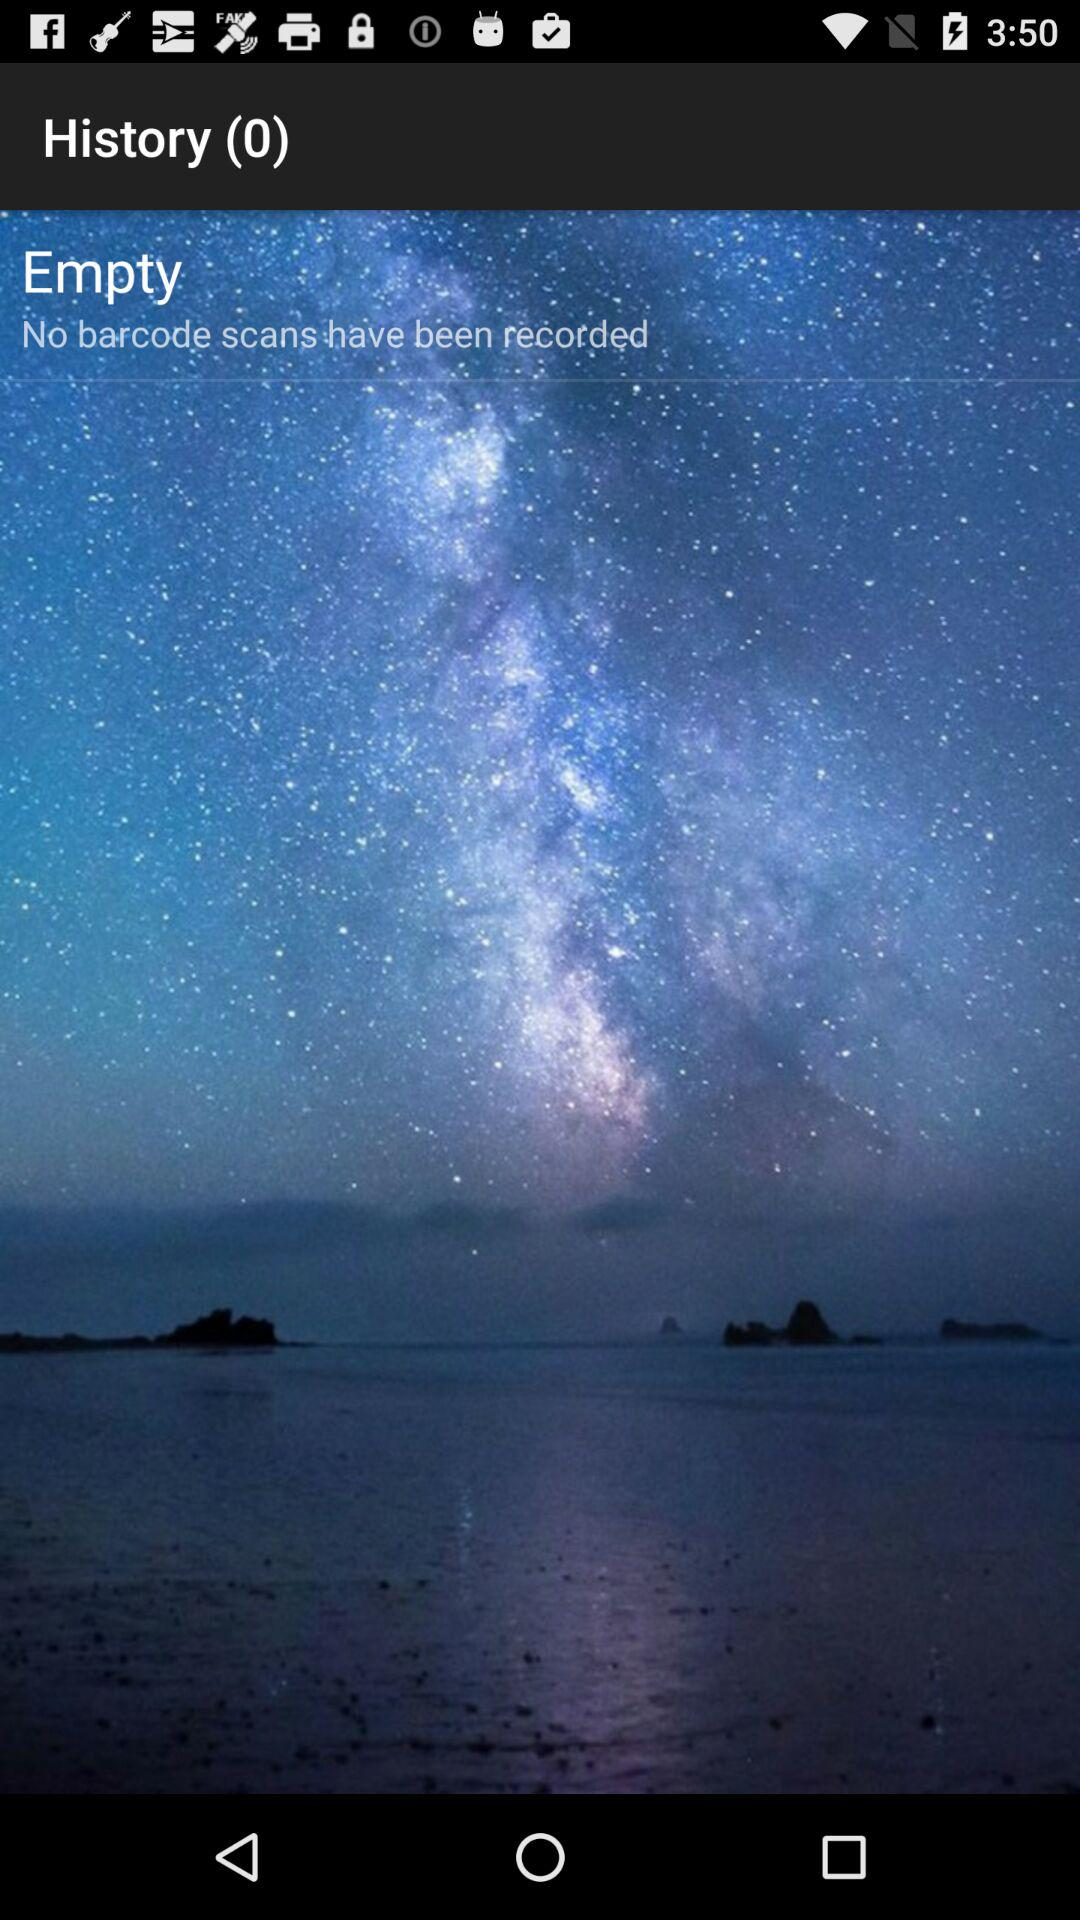How many more empty fields are there than barcode scans?
Answer the question using a single word or phrase. 1 